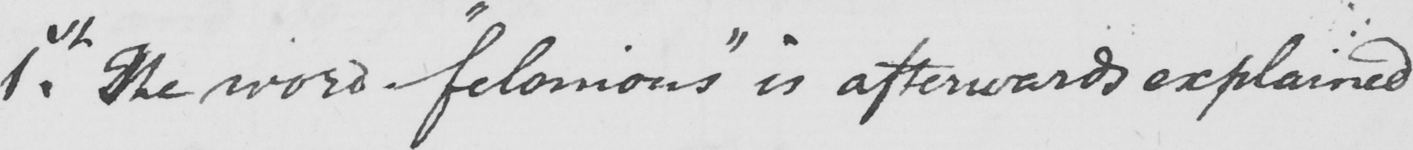Can you read and transcribe this handwriting? 1st . The word  " felonious "  is afterwards explained 